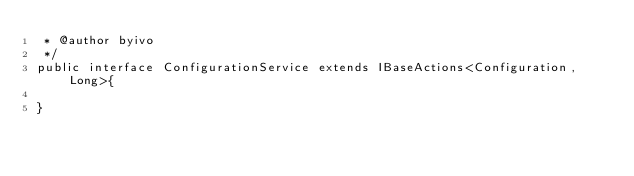Convert code to text. <code><loc_0><loc_0><loc_500><loc_500><_Java_> * @author byivo
 */
public interface ConfigurationService extends IBaseActions<Configuration, Long>{
    
}
</code> 